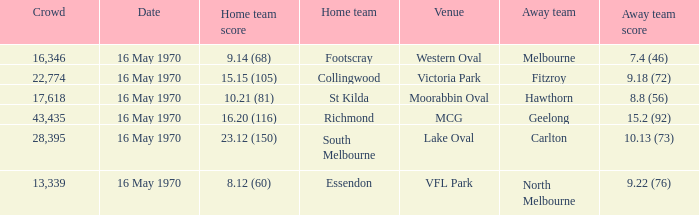Who was the away team at western oval? Melbourne. 